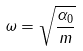<formula> <loc_0><loc_0><loc_500><loc_500>\omega = \sqrt { \frac { \alpha _ { 0 } } { m } }</formula> 